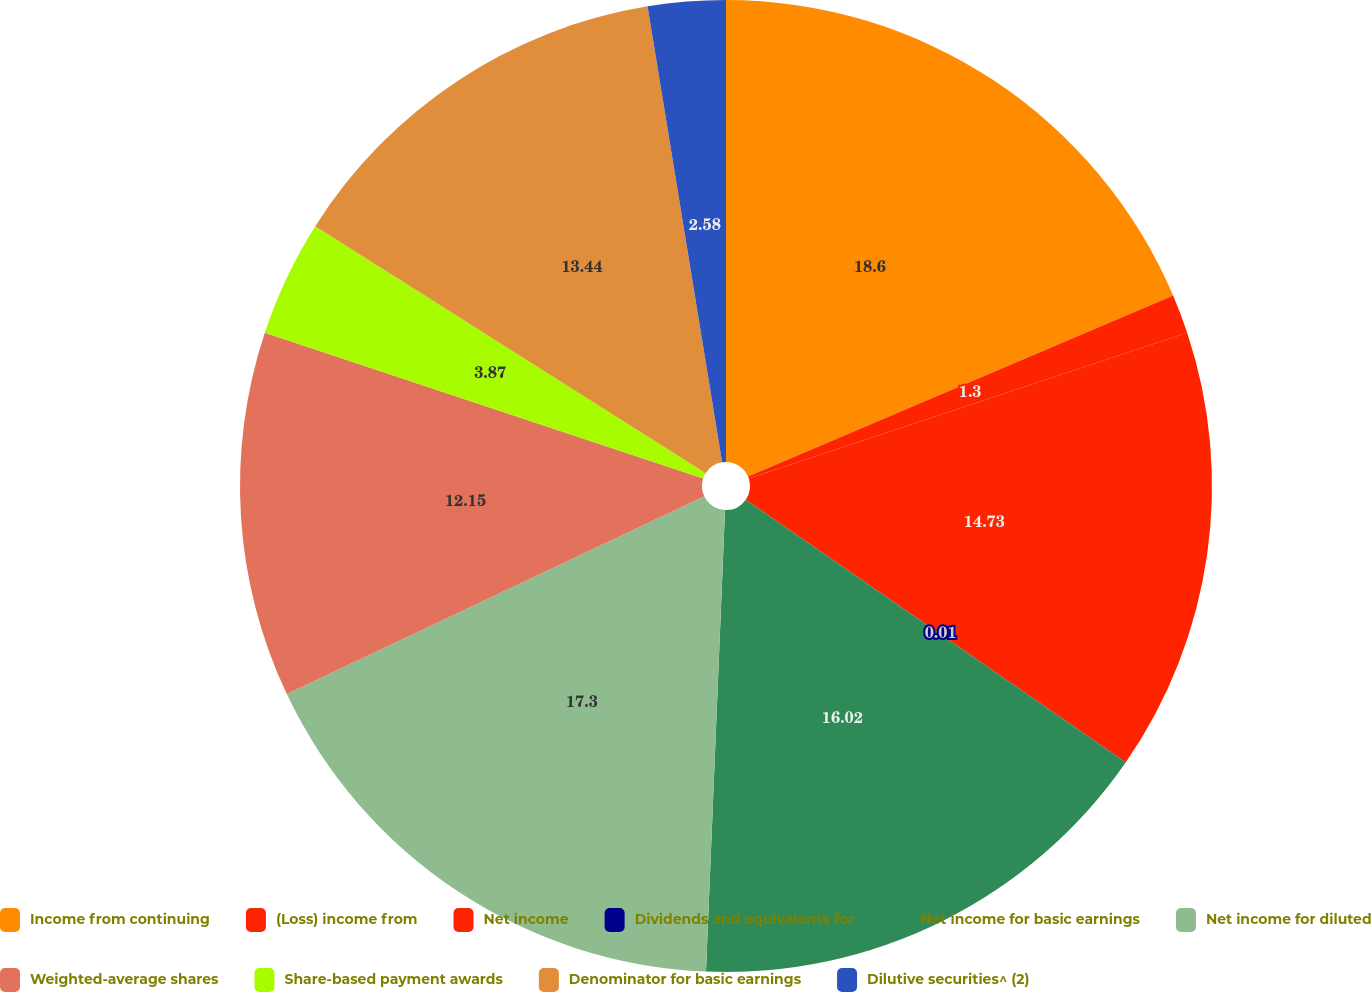Convert chart to OTSL. <chart><loc_0><loc_0><loc_500><loc_500><pie_chart><fcel>Income from continuing<fcel>(Loss) income from<fcel>Net income<fcel>Dividends and equivalents for<fcel>Net income for basic earnings<fcel>Net income for diluted<fcel>Weighted-average shares<fcel>Share-based payment awards<fcel>Denominator for basic earnings<fcel>Dilutive securities^ (2)<nl><fcel>18.59%<fcel>1.3%<fcel>14.73%<fcel>0.01%<fcel>16.02%<fcel>17.3%<fcel>12.15%<fcel>3.87%<fcel>13.44%<fcel>2.58%<nl></chart> 